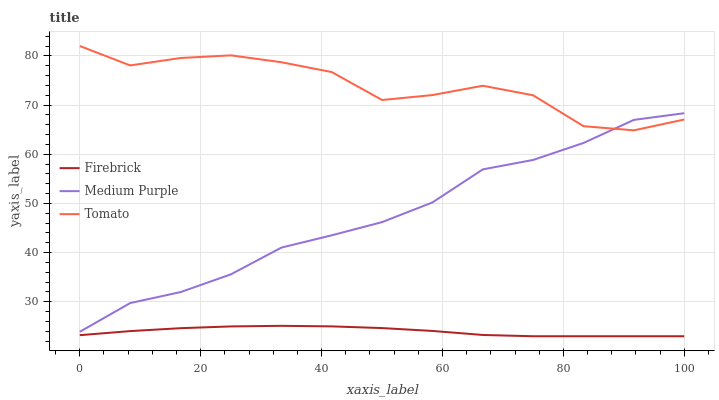Does Tomato have the minimum area under the curve?
Answer yes or no. No. Does Firebrick have the maximum area under the curve?
Answer yes or no. No. Is Tomato the smoothest?
Answer yes or no. No. Is Firebrick the roughest?
Answer yes or no. No. Does Tomato have the lowest value?
Answer yes or no. No. Does Firebrick have the highest value?
Answer yes or no. No. Is Firebrick less than Tomato?
Answer yes or no. Yes. Is Tomato greater than Firebrick?
Answer yes or no. Yes. Does Firebrick intersect Tomato?
Answer yes or no. No. 